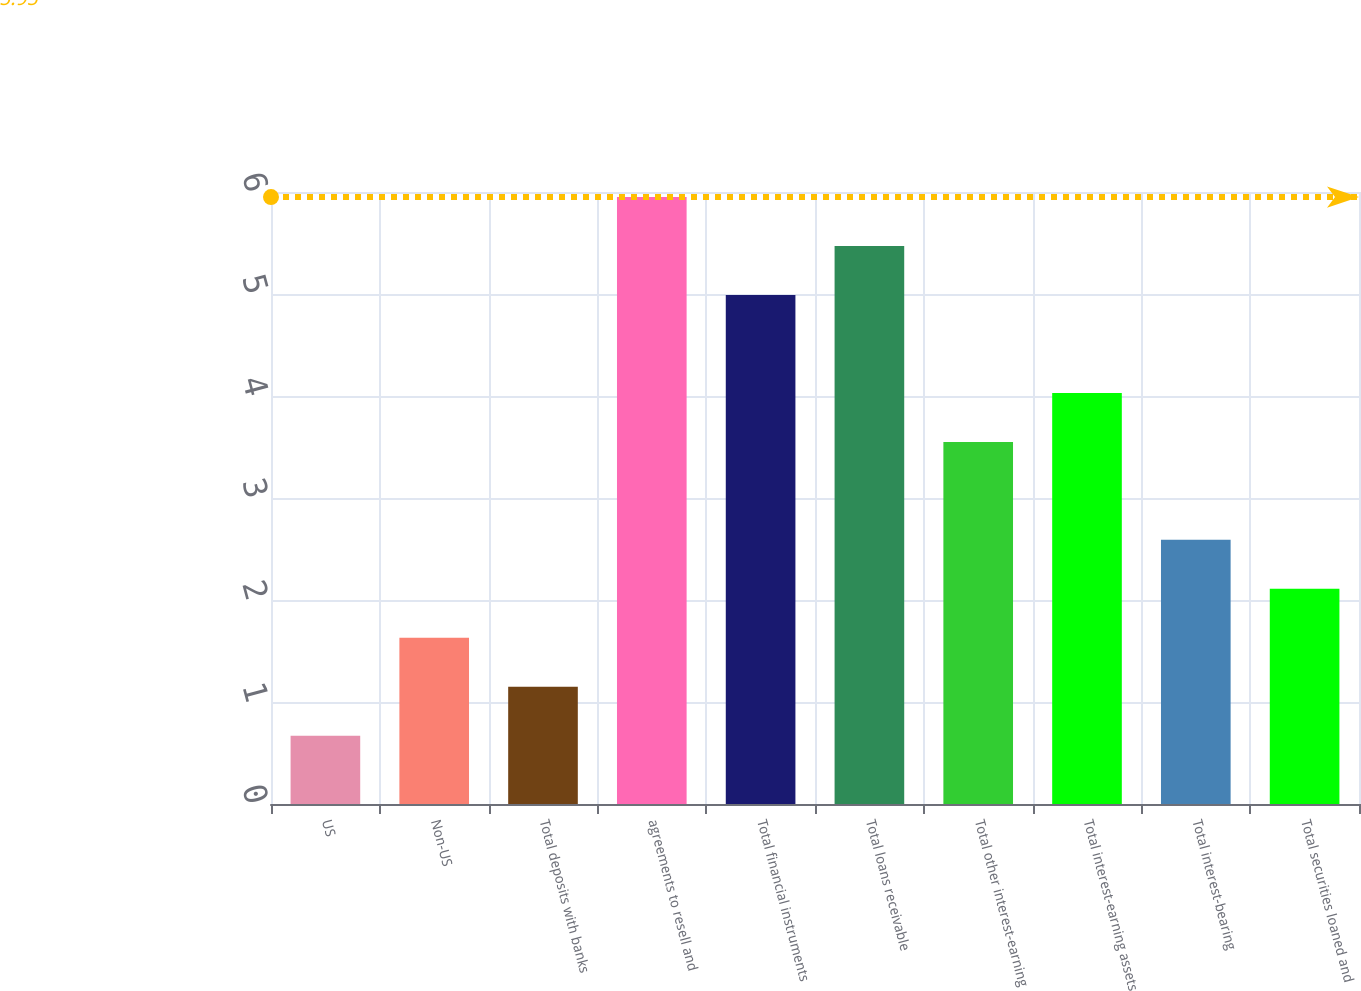Convert chart to OTSL. <chart><loc_0><loc_0><loc_500><loc_500><bar_chart><fcel>US<fcel>Non-US<fcel>Total deposits with banks<fcel>agreements to resell and<fcel>Total financial instruments<fcel>Total loans receivable<fcel>Total other interest-earning<fcel>Total interest-earning assets<fcel>Total interest-bearing<fcel>Total securities loaned and<nl><fcel>0.67<fcel>1.63<fcel>1.15<fcel>5.95<fcel>4.99<fcel>5.47<fcel>3.55<fcel>4.03<fcel>2.59<fcel>2.11<nl></chart> 